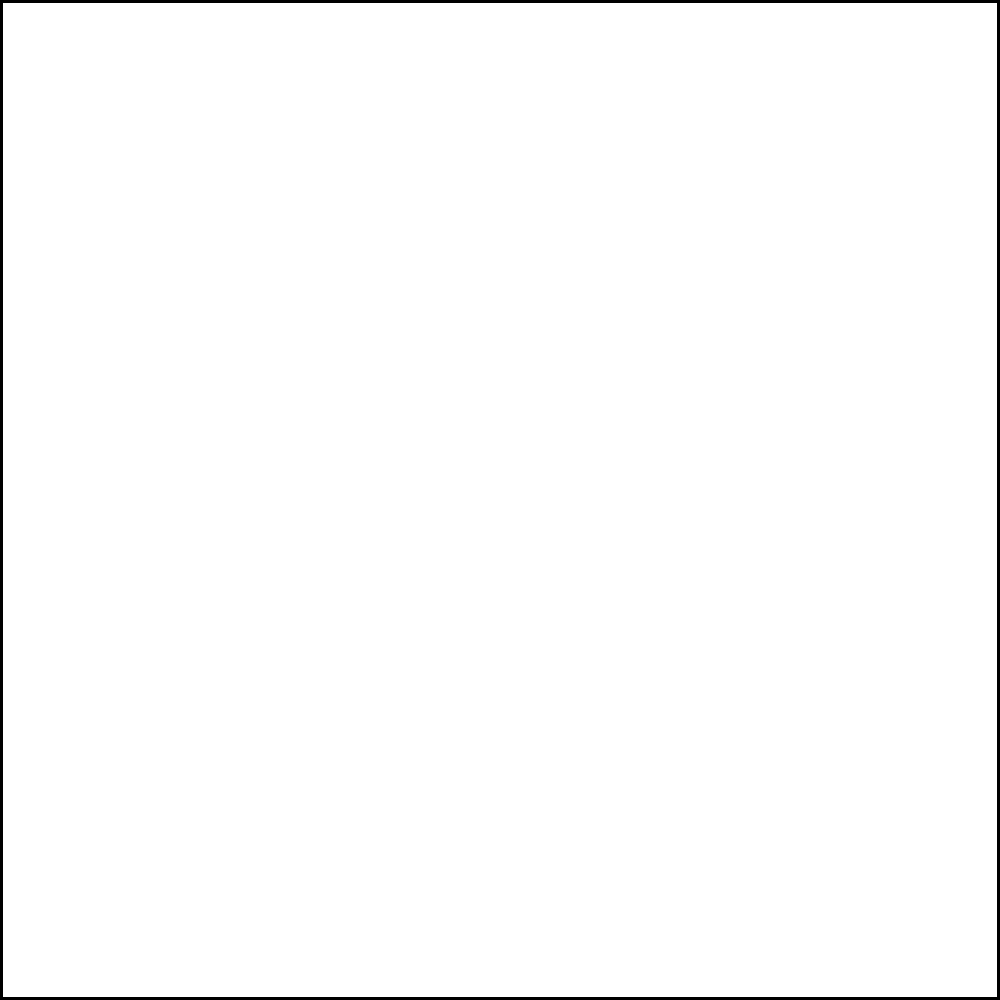In the network diagram representing player positions and passing patterns on a football field, what is the minimum number of passes required to get the ball from player $v_1$ to player $v_5$? To solve this problem, we need to find the shortest path from $v_1$ to $v_5$ in the given network diagram. Let's follow these steps:

1. Identify all possible paths from $v_1$ to $v_5$:
   a) $v_1 \rightarrow v_2 \rightarrow v_4 \rightarrow v_5$
   b) $v_1 \rightarrow v_4 \rightarrow v_5$
   c) $v_1 \rightarrow v_2 \rightarrow v_3 \rightarrow v_5$

2. Count the number of passes (edges) in each path:
   a) Path a: 3 passes
   b) Path b: 2 passes
   c) Path c: 3 passes

3. Determine the minimum number of passes:
   The shortest path is path b, which requires 2 passes.

Therefore, the minimum number of passes required to get the ball from player $v_1$ to player $v_5$ is 2.
Answer: 2 passes 